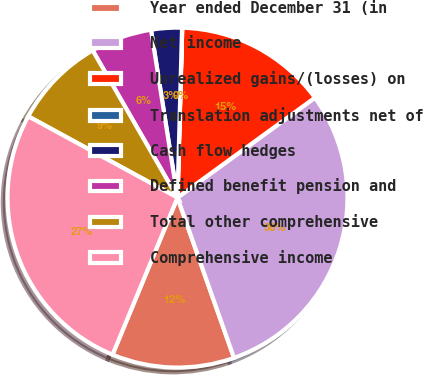Convert chart to OTSL. <chart><loc_0><loc_0><loc_500><loc_500><pie_chart><fcel>Year ended December 31 (in<fcel>Net income<fcel>Unrealized gains/(losses) on<fcel>Translation adjustments net of<fcel>Cash flow hedges<fcel>Defined benefit pension and<fcel>Total other comprehensive<fcel>Comprehensive income<nl><fcel>11.64%<fcel>29.61%<fcel>14.55%<fcel>0.02%<fcel>2.92%<fcel>5.83%<fcel>8.74%<fcel>26.7%<nl></chart> 